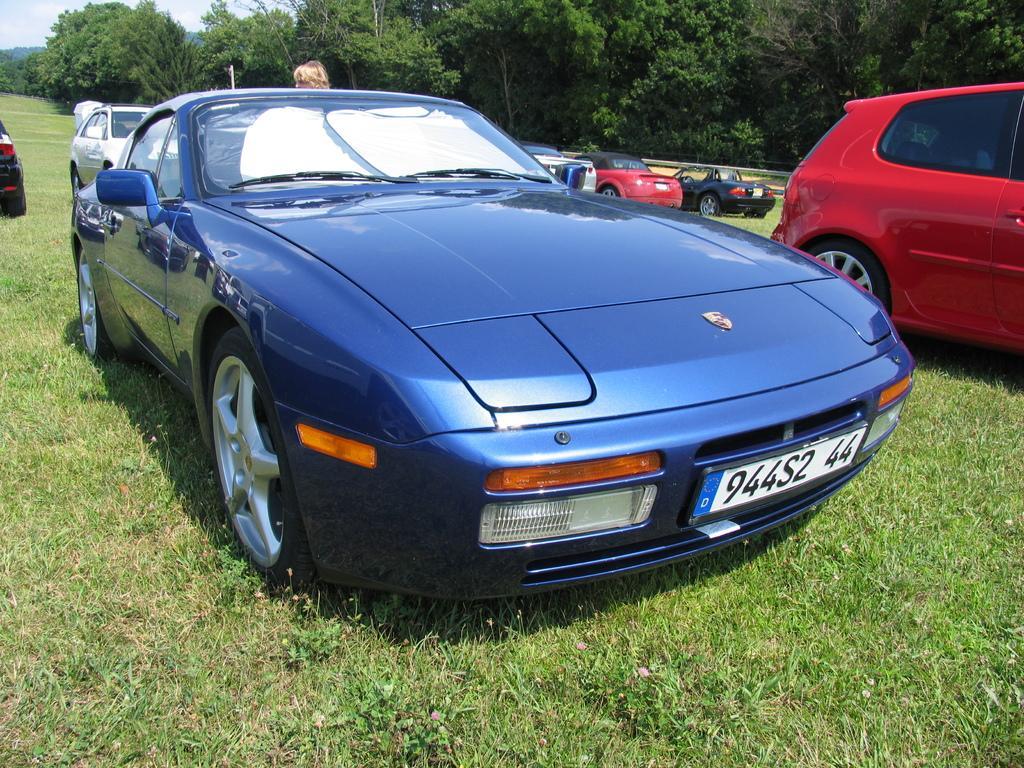Can you describe this image briefly? In this image, we can see some cars and there's grass on the ground, we can see some trees, we can also see the sky. 